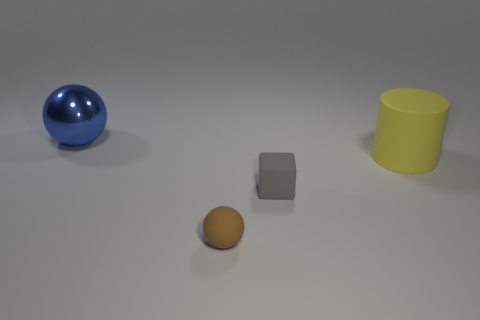Add 1 large things. How many objects exist? 5 Subtract all cubes. How many objects are left? 3 Subtract all purple cubes. How many green balls are left? 0 Add 2 big shiny balls. How many big shiny balls exist? 3 Subtract all blue balls. How many balls are left? 1 Subtract 0 blue cylinders. How many objects are left? 4 Subtract 1 cylinders. How many cylinders are left? 0 Subtract all yellow blocks. Subtract all purple spheres. How many blocks are left? 1 Subtract all small brown blocks. Subtract all large rubber things. How many objects are left? 3 Add 1 tiny blocks. How many tiny blocks are left? 2 